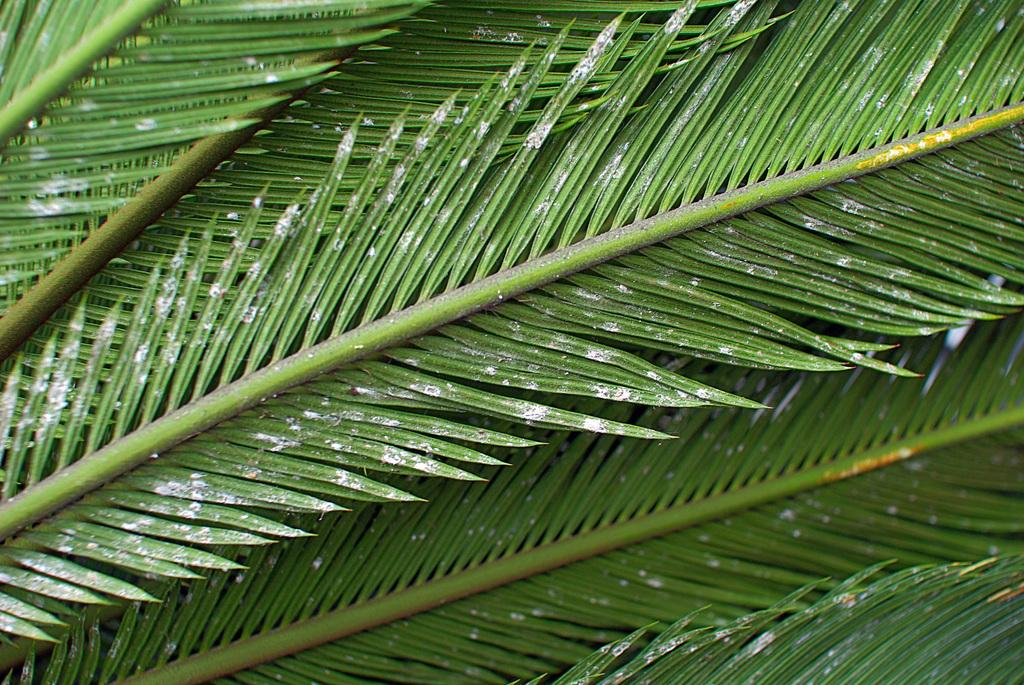What type of vegetation is present in the image? The image contains leaves. What color are the leaves in the image? The leaves belong to a green tree. What type of wool can be seen on the leaves in the image? There is no wool present on the leaves in the image; they are simply green leaves from a tree. 